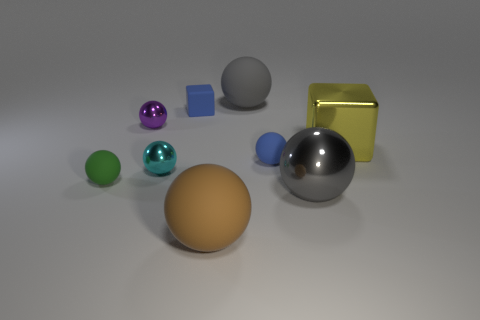Subtract all tiny purple spheres. How many spheres are left? 6 Subtract all green spheres. How many spheres are left? 6 Subtract all gray spheres. Subtract all brown cylinders. How many spheres are left? 5 Add 1 small purple blocks. How many objects exist? 10 Subtract all spheres. How many objects are left? 2 Subtract 0 gray cylinders. How many objects are left? 9 Subtract all yellow shiny things. Subtract all big yellow metallic blocks. How many objects are left? 7 Add 7 purple things. How many purple things are left? 8 Add 2 tiny blue matte cubes. How many tiny blue matte cubes exist? 3 